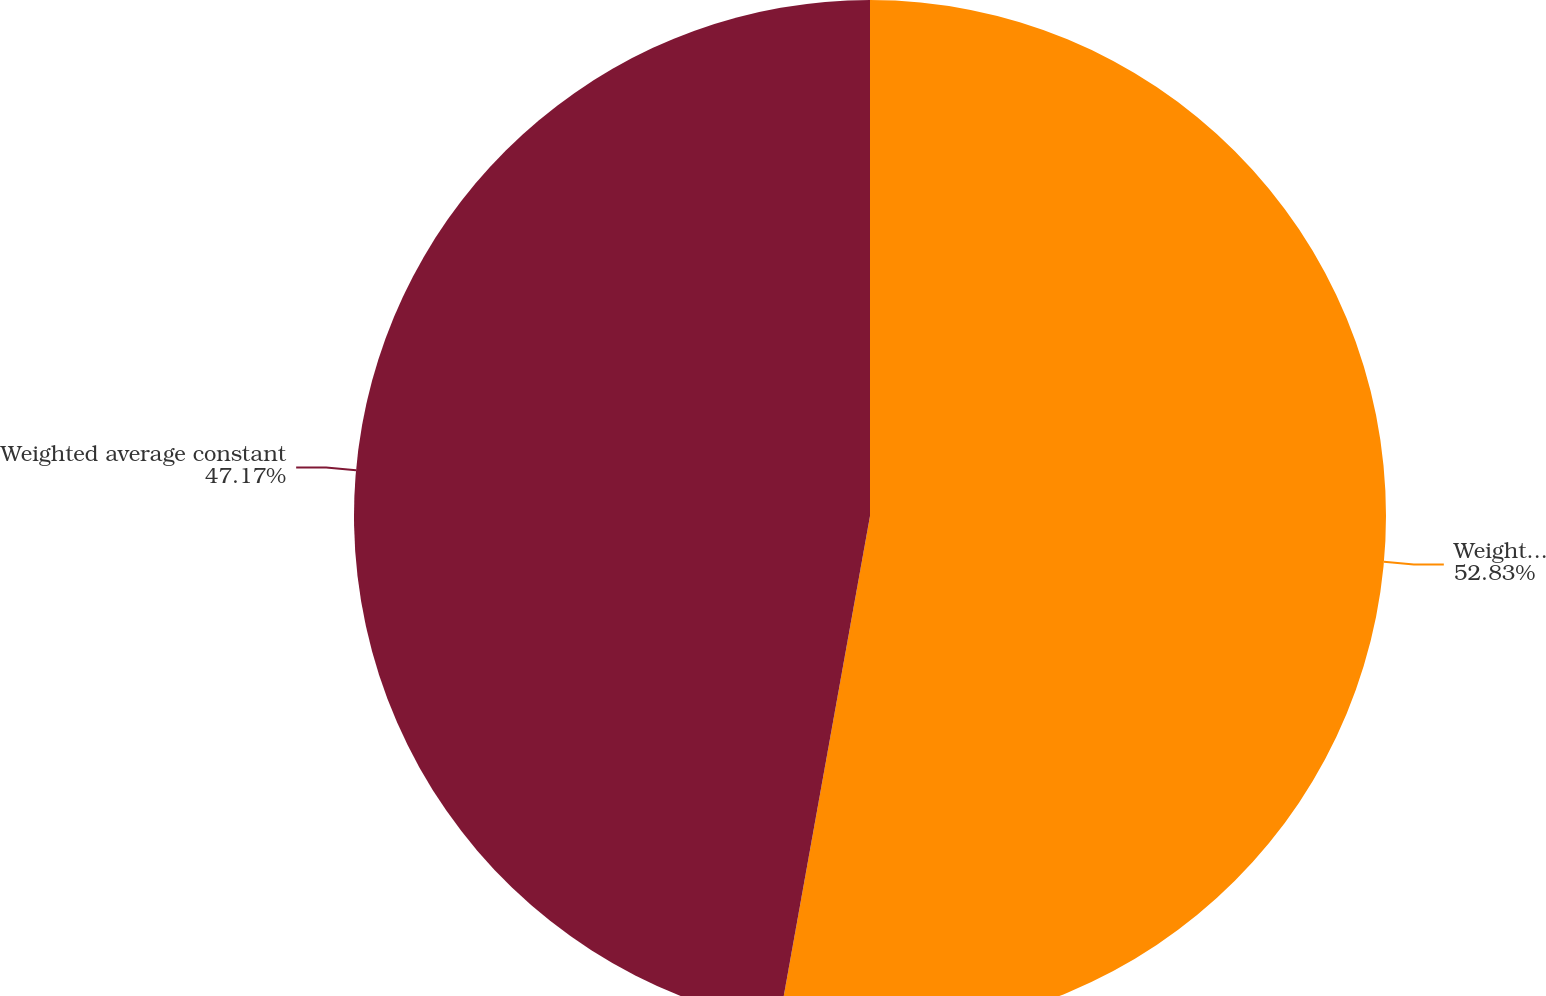Convert chart to OTSL. <chart><loc_0><loc_0><loc_500><loc_500><pie_chart><fcel>Weighted average discount rate<fcel>Weighted average constant<nl><fcel>52.83%<fcel>47.17%<nl></chart> 